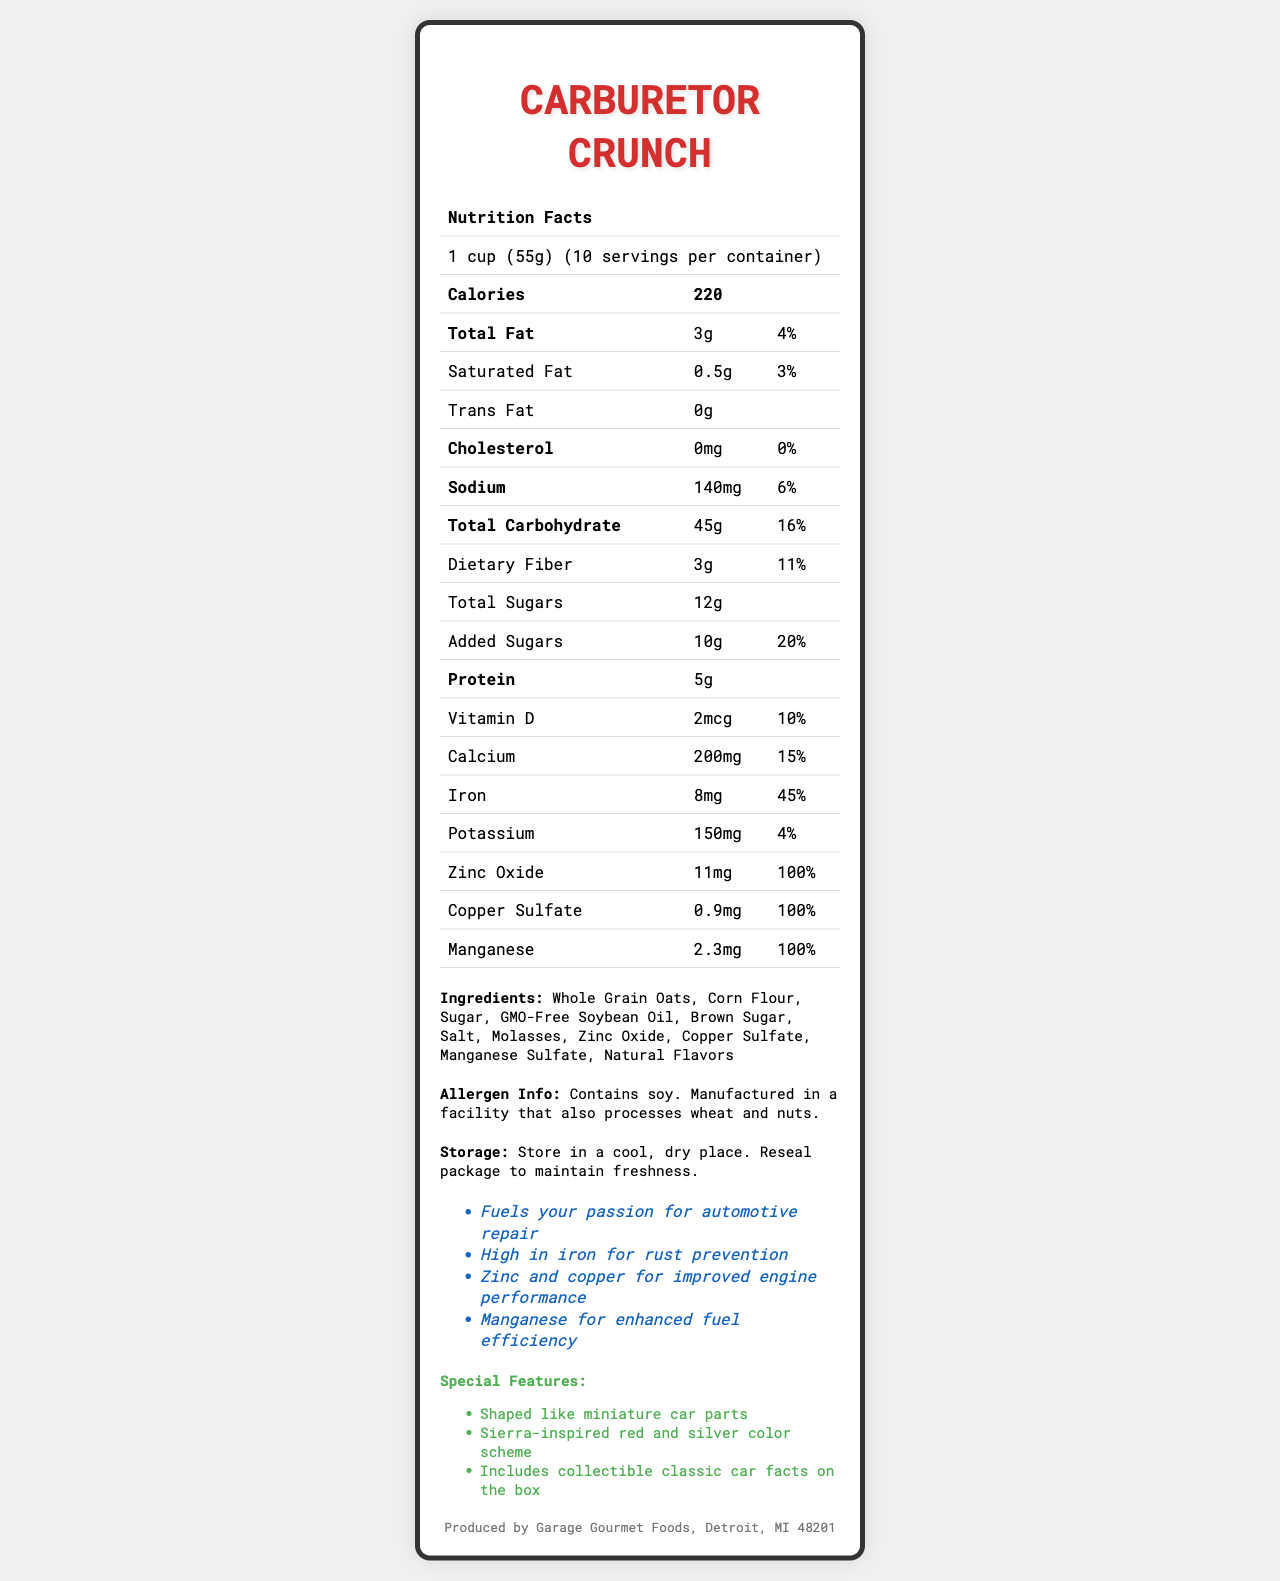what is the serving size of Carburetor Crunch? The serving size is explicitly mentioned as "1 cup (55g)" in the document.
Answer: 1 cup (55g) how many servings are there per container? The document states that there are 10 servings per container.
Answer: 10 how much protein does one serving of Carburetor Crunch provide? According to the nutrition facts, one serving provides 5g of protein.
Answer: 5g what is the total fat content per serving, and what percentage of the daily value does it represent? The total fat content per serving is 3g, which represents 4% of the daily value.
Answer: 3g, 4% how many grams of dietary fiber does each serving of Carburetor Crunch contain? The dietary fiber content per serving is listed as 3g.
Answer: 3g what is the amount of added sugars per serving, and what is its daily value percentage? The document notes that each serving contains 10g of added sugars, accounting for 20% of the daily value.
Answer: 10g, 20% what kind of oil is used in the ingredients? The ingredient list includes "GMO-Free Soybean Oil."
Answer: GMO-Free Soybean Oil does Carburetor Crunch contain any allergens? The allergen information states that it contains soy and is manufactured in a facility that processes wheat and nuts.
Answer: Yes which ingredient is listed first in the ingredient list? Whole Grain Oats is the first ingredient listed.
Answer: Whole Grain Oats what vitamins and minerals are present in Carburetor Crunch, and their respective daily values? The vitamins and minerals and their daily values are: Vitamin D (10%), Calcium (15%), Iron (45%), Zinc (100%), Copper (100%), and Manganese (100%).
Answer: Vitamin D 10%, Calcium 15%, Iron 45%, Zinc 100%, Copper 100%, Manganese 100% what are some of the marketing claims made for Carburetor Crunch? The marketing claims listed in the document are: "Fuels your passion for automotive repair," "High in iron for rust prevention," "Zinc and copper for improved engine performance," and "Manganese for enhanced fuel efficiency."
Answer: Fuels your passion for automotive repair; High in iron for rust prevention; Zinc and copper for improved engine performance; Manganese for enhanced fuel efficiency what is the main theme of Carburetor Crunch based on its marketing and special features? The marketing claims and special features emphasize automotive themes, indicating that the cereal is designed for automotive enthusiasts.
Answer: Automotive Enthusiasm how many grams of total sugars are there in one serving of Carburetor Crunch? A. 10g, B. 8g, C. 12g, D. 15g The document lists the total sugars per serving as 12g.
Answer: C. 12g which organization manufactures Carburetor Crunch? A. Engine Edibles, B. Gearhead Grains, C. Garage Gourmet Foods, D. Car Care Cereal Co. According to the manufacturer information, Garage Gourmet Foods produces Carburetor Crunch.
Answer: C. Garage Gourmet Foods is Sierra car mentioned on the Nutrition Facts Label? Sierra car is not mentioned in the document.
Answer: No what is a special feature about the shapes of the cereal pieces? One of the special features mentions that the cereal pieces are shaped like miniature car parts.
Answer: Shaped like miniature car parts what is the main idea of the Carburetor Crunch nutrition facts label? The label outlines the product’s theme, nutritional content, marketing claims, ingredients, and special features, all centered around automotive themes.
Answer: Carburetor Crunch is a car-themed cereal designed for automotive enthusiasts, offering essential nutrients and unique features like car-shaped pieces, while providing specific nutritional information per serving. are there instructions on how to store Carburetor Crunch? The document provides storage instructions: "Store in a cool, dry place. Reseal package to maintain freshness."
Answer: Yes where can I buy Carburetor Crunch? The document does not provide information on where to purchase Carburetor Crunch.
Answer: Cannot be determined what colors are used in the cereal according to the special features section? The special features mention a Sierra-inspired red and silver color scheme.
Answer: Red and Silver 